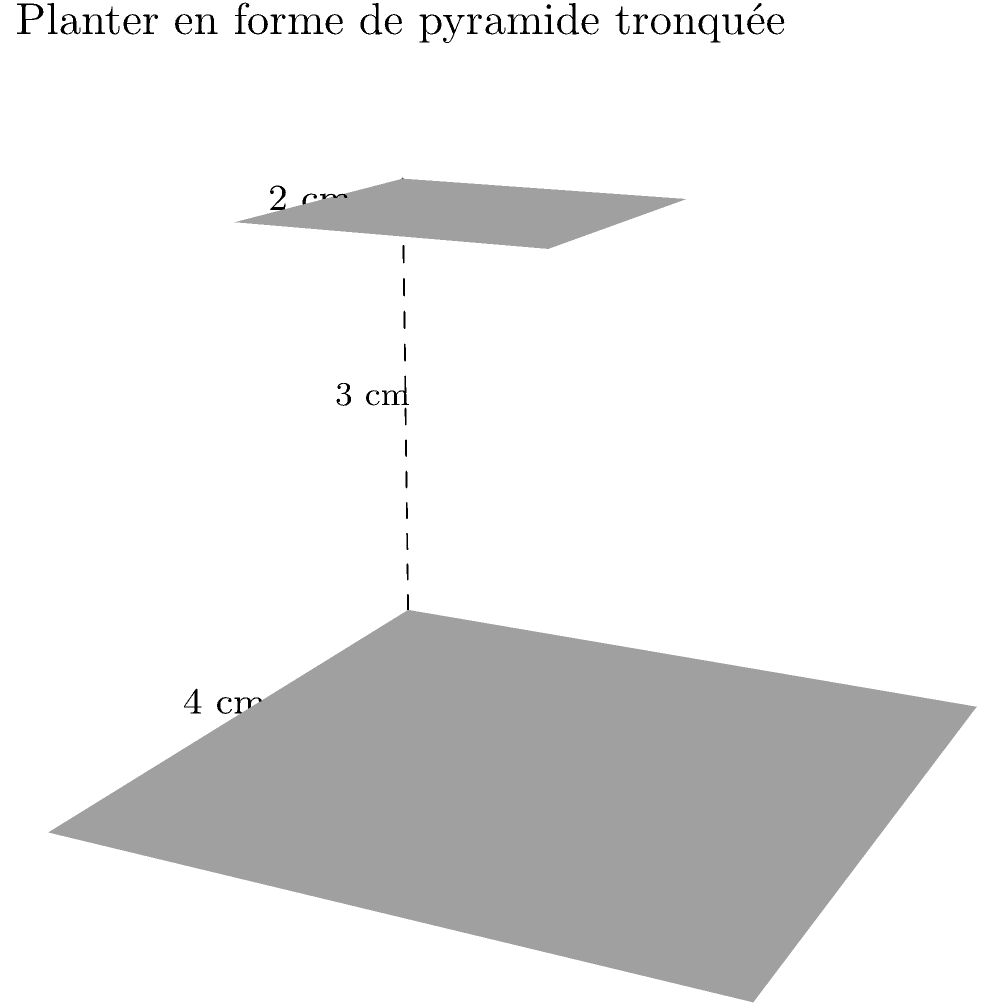Vous souhaitez créer un pot de fleurs unique pour votre prochain projet de bricolage. Vous avez conçu un pot en forme de pyramide tronquée avec une base carrée de 4 cm de côté, une face supérieure carrée de 2 cm de côté, et une hauteur de 3 cm. Quel est le volume de ce pot de fleurs en centimètres cubes? Pour calculer le volume d'une pyramide tronquée, nous utilisons la formule suivante:

$$V = \frac{1}{3}h(A_1 + A_2 + \sqrt{A_1A_2})$$

Où:
$V$ = volume
$h$ = hauteur
$A_1$ = aire de la base inférieure
$A_2$ = aire de la base supérieure

Étapes de calcul:

1. Calculer $A_1$: 
   $A_1 = 4^2 = 16$ cm²

2. Calculer $A_2$:
   $A_2 = 2^2 = 4$ cm²

3. Calculer $\sqrt{A_1A_2}$:
   $\sqrt{A_1A_2} = \sqrt{16 \times 4} = \sqrt{64} = 8$ cm²

4. Appliquer la formule:
   $$V = \frac{1}{3} \times 3 \times (16 + 4 + 8)$$
   $$V = 1 \times 28 = 28$$ cm³

Donc, le volume du pot de fleurs est de 28 centimètres cubes.
Answer: 28 cm³ 